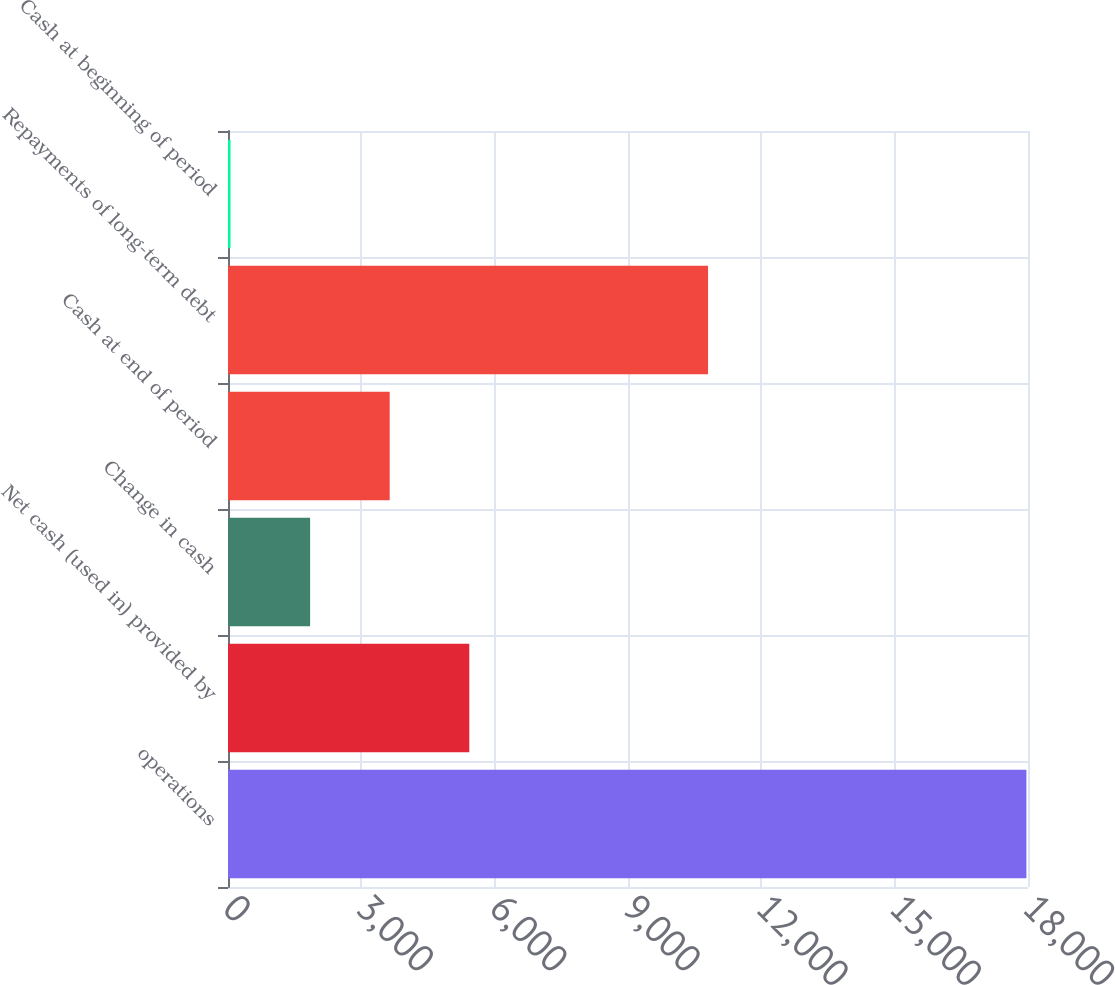Convert chart. <chart><loc_0><loc_0><loc_500><loc_500><bar_chart><fcel>operations<fcel>Net cash (used in) provided by<fcel>Change in cash<fcel>Cash at end of period<fcel>Repayments of long-term debt<fcel>Cash at beginning of period<nl><fcel>17964<fcel>5429.1<fcel>1847.7<fcel>3638.4<fcel>10801.2<fcel>57<nl></chart> 